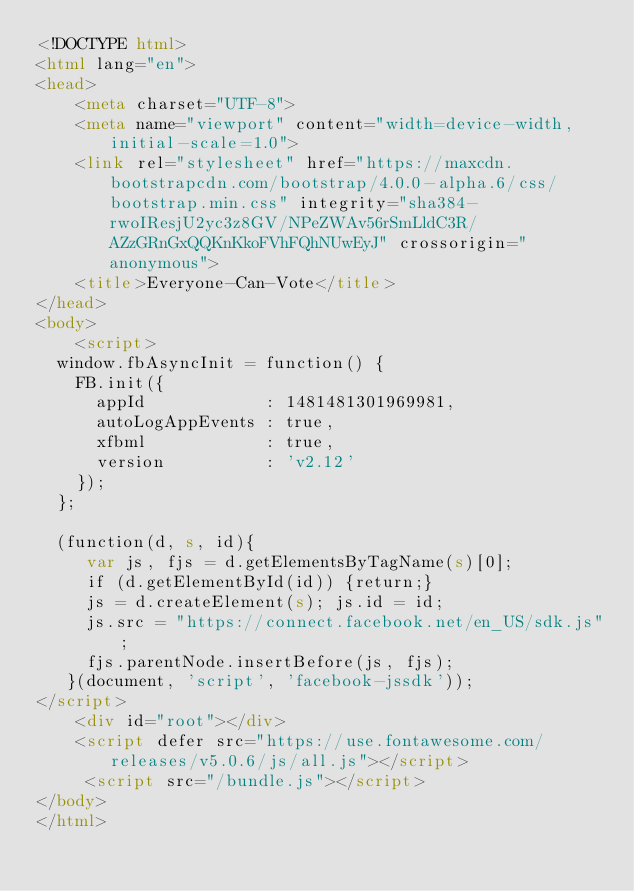Convert code to text. <code><loc_0><loc_0><loc_500><loc_500><_HTML_><!DOCTYPE html>
<html lang="en">
<head>
    <meta charset="UTF-8">
    <meta name="viewport" content="width=device-width, initial-scale=1.0">
    <link rel="stylesheet" href="https://maxcdn.bootstrapcdn.com/bootstrap/4.0.0-alpha.6/css/bootstrap.min.css" integrity="sha384-rwoIResjU2yc3z8GV/NPeZWAv56rSmLldC3R/AZzGRnGxQQKnKkoFVhFQhNUwEyJ" crossorigin="anonymous">
    <title>Everyone-Can-Vote</title>
</head>
<body>
    <script>
  window.fbAsyncInit = function() {
    FB.init({
      appId            : 1481481301969981,
      autoLogAppEvents : true,
      xfbml            : true,
      version          : 'v2.12'
    });
  };

  (function(d, s, id){
     var js, fjs = d.getElementsByTagName(s)[0];
     if (d.getElementById(id)) {return;}
     js = d.createElement(s); js.id = id;
     js.src = "https://connect.facebook.net/en_US/sdk.js";
     fjs.parentNode.insertBefore(js, fjs);
   }(document, 'script', 'facebook-jssdk'));
</script>
    <div id="root"></div>
    <script defer src="https://use.fontawesome.com/releases/v5.0.6/js/all.js"></script>
     <script src="/bundle.js"></script>
</body>
</html></code> 